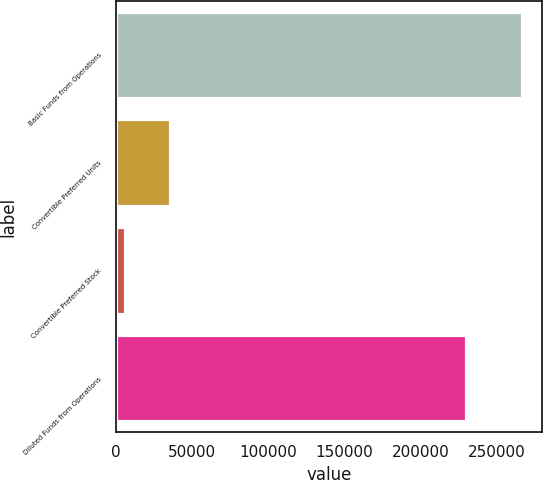Convert chart to OTSL. <chart><loc_0><loc_0><loc_500><loc_500><bar_chart><fcel>Basic Funds from Operations<fcel>Convertible Preferred Units<fcel>Convertible Preferred Stock<fcel>Diluted Funds from Operations<nl><fcel>266631<fcel>35139.9<fcel>5834<fcel>229961<nl></chart> 